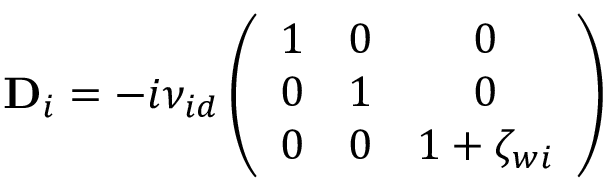<formula> <loc_0><loc_0><loc_500><loc_500>D _ { i } = - i { \nu _ { i d } } \left ( \begin{array} { c c c } { 1 } & { 0 } & { 0 } \\ { 0 } & { 1 } & { 0 } \\ { 0 } & { 0 } & { 1 + \zeta _ { w i } } \end{array} \right )</formula> 